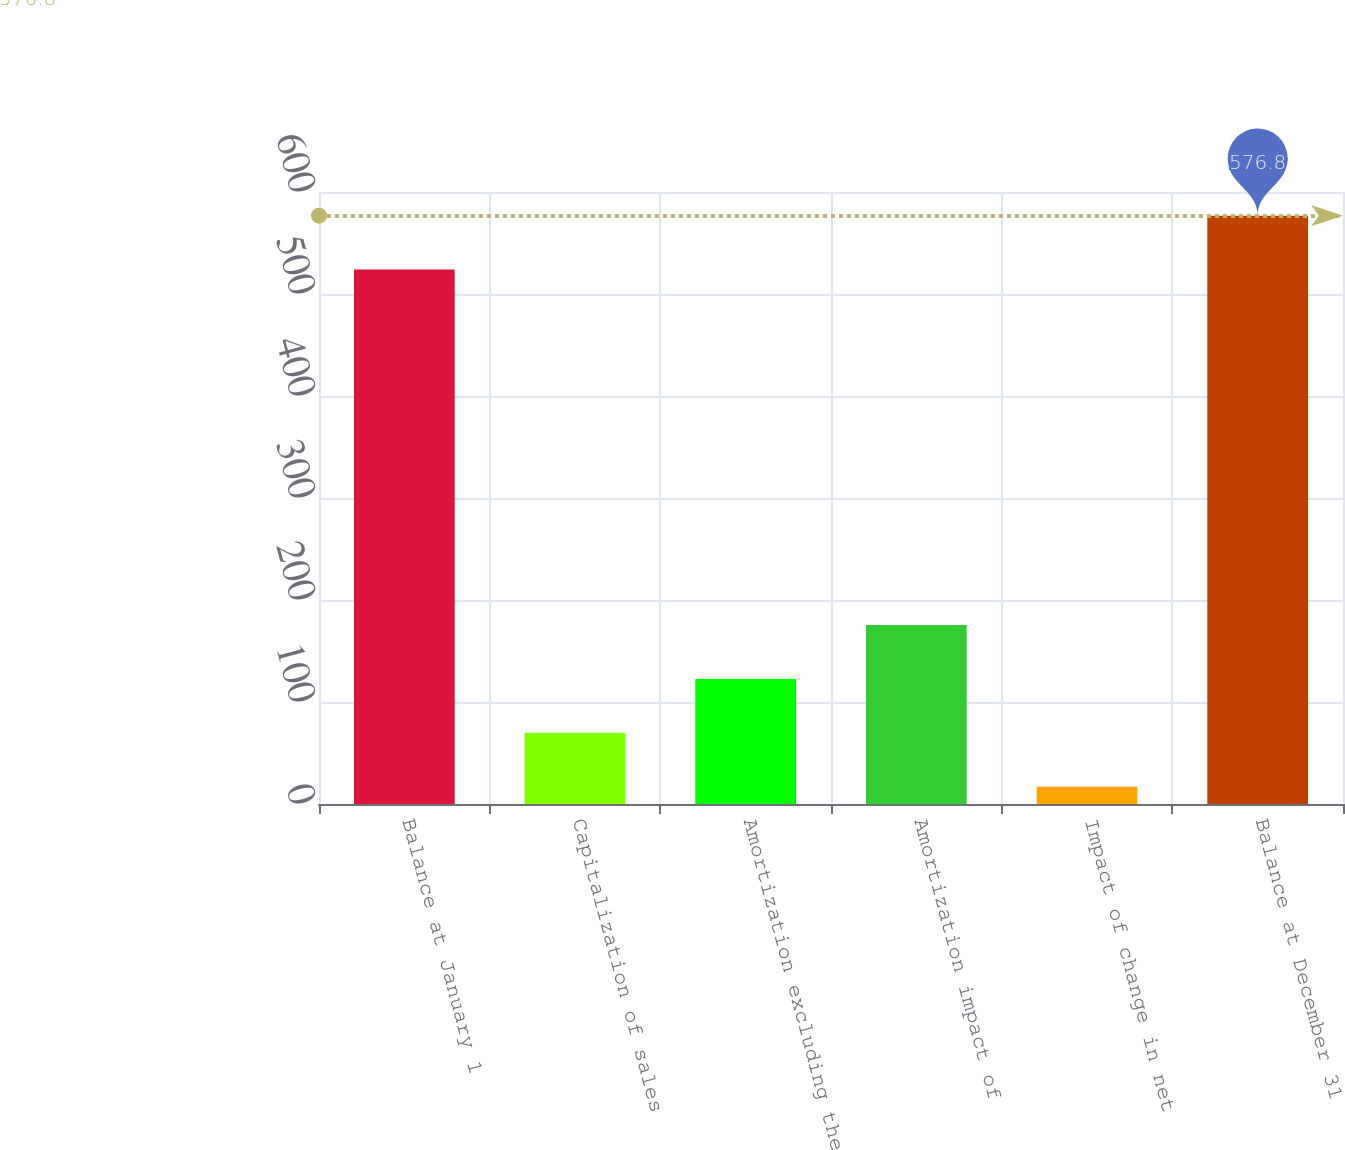<chart> <loc_0><loc_0><loc_500><loc_500><bar_chart><fcel>Balance at January 1<fcel>Capitalization of sales<fcel>Amortization excluding the<fcel>Amortization impact of<fcel>Impact of change in net<fcel>Balance at December 31<nl><fcel>524<fcel>69.8<fcel>122.6<fcel>175.4<fcel>17<fcel>576.8<nl></chart> 